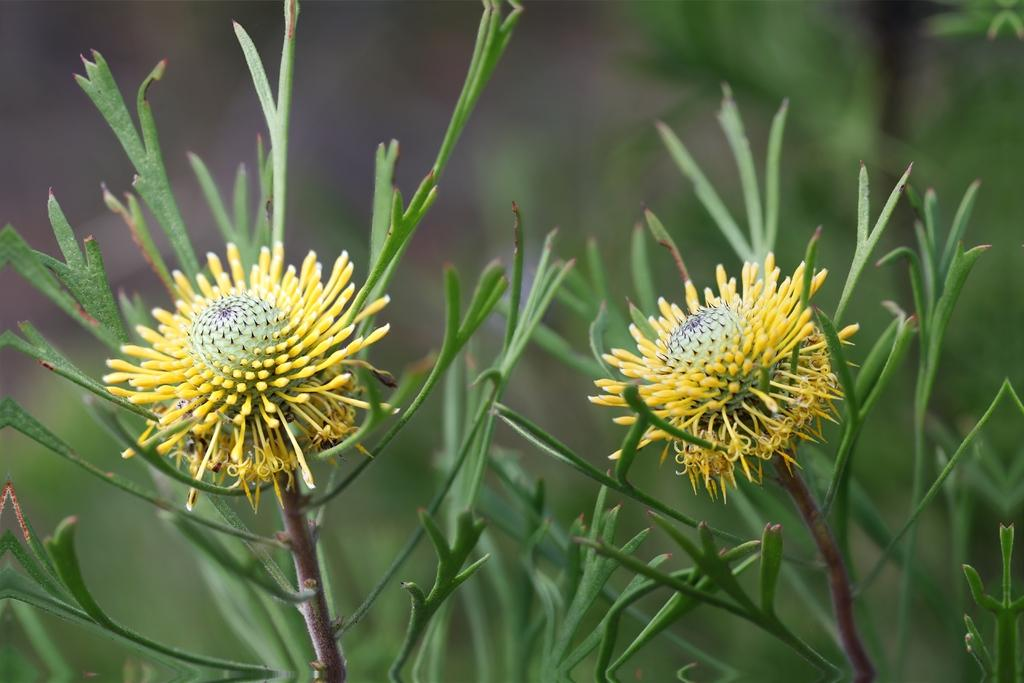Where was the image taken? The image is taken outdoors. What can be seen in the image besides the outdoor setting? There are plants with flowers in the image. What color are the flowers? The flowers are yellow in color. What type of achievement is being celebrated by the flowers in the image? There is no indication in the image that the flowers are celebrating any achievements. 